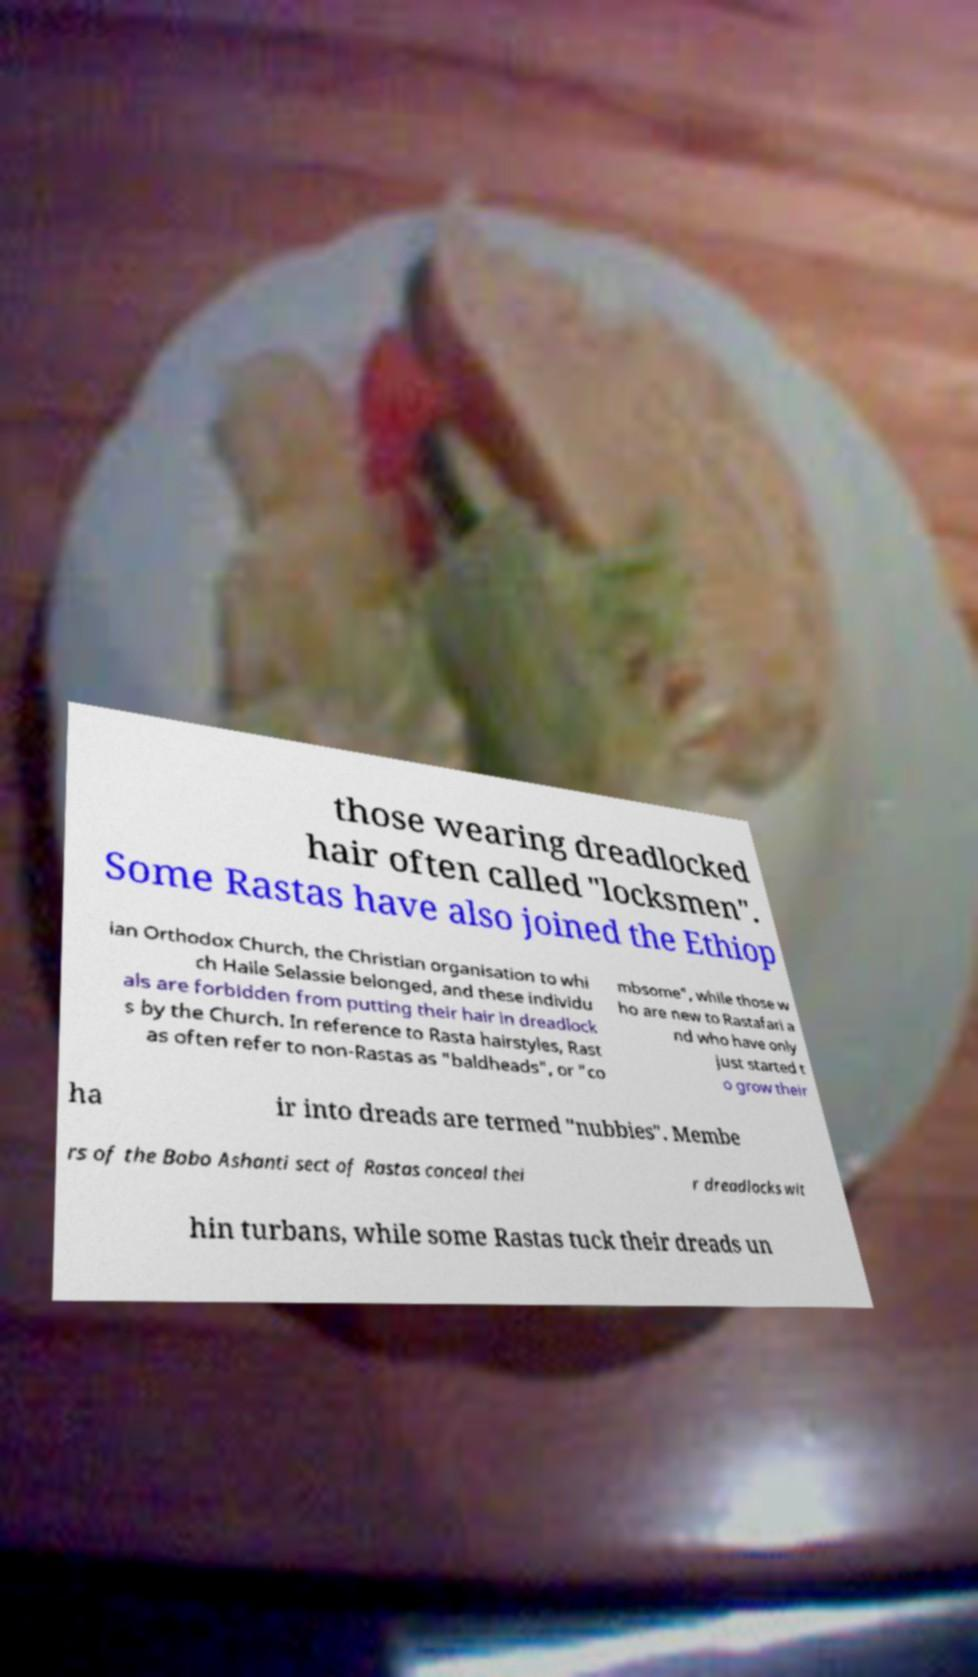For documentation purposes, I need the text within this image transcribed. Could you provide that? those wearing dreadlocked hair often called "locksmen". Some Rastas have also joined the Ethiop ian Orthodox Church, the Christian organisation to whi ch Haile Selassie belonged, and these individu als are forbidden from putting their hair in dreadlock s by the Church. In reference to Rasta hairstyles, Rast as often refer to non-Rastas as "baldheads", or "co mbsome", while those w ho are new to Rastafari a nd who have only just started t o grow their ha ir into dreads are termed "nubbies". Membe rs of the Bobo Ashanti sect of Rastas conceal thei r dreadlocks wit hin turbans, while some Rastas tuck their dreads un 